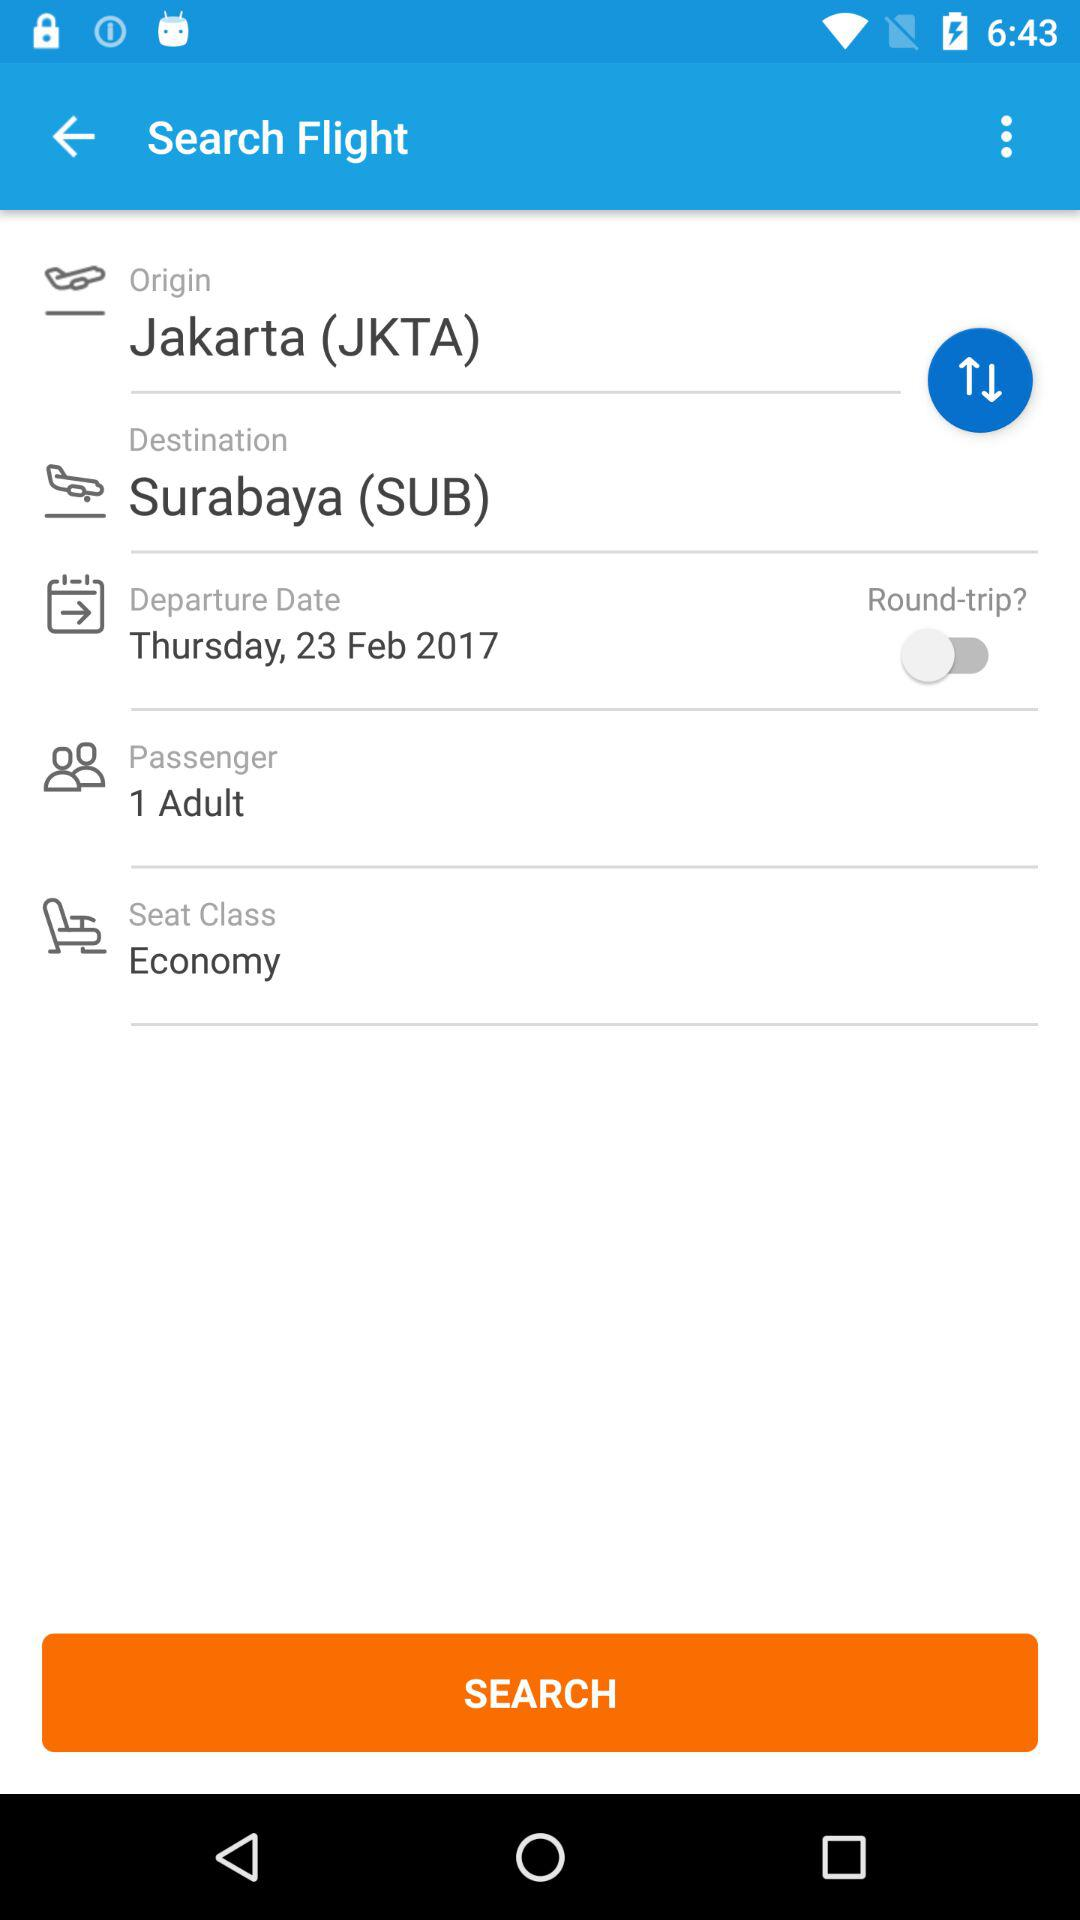What is the count of passengers? The count of passengers is 1. 